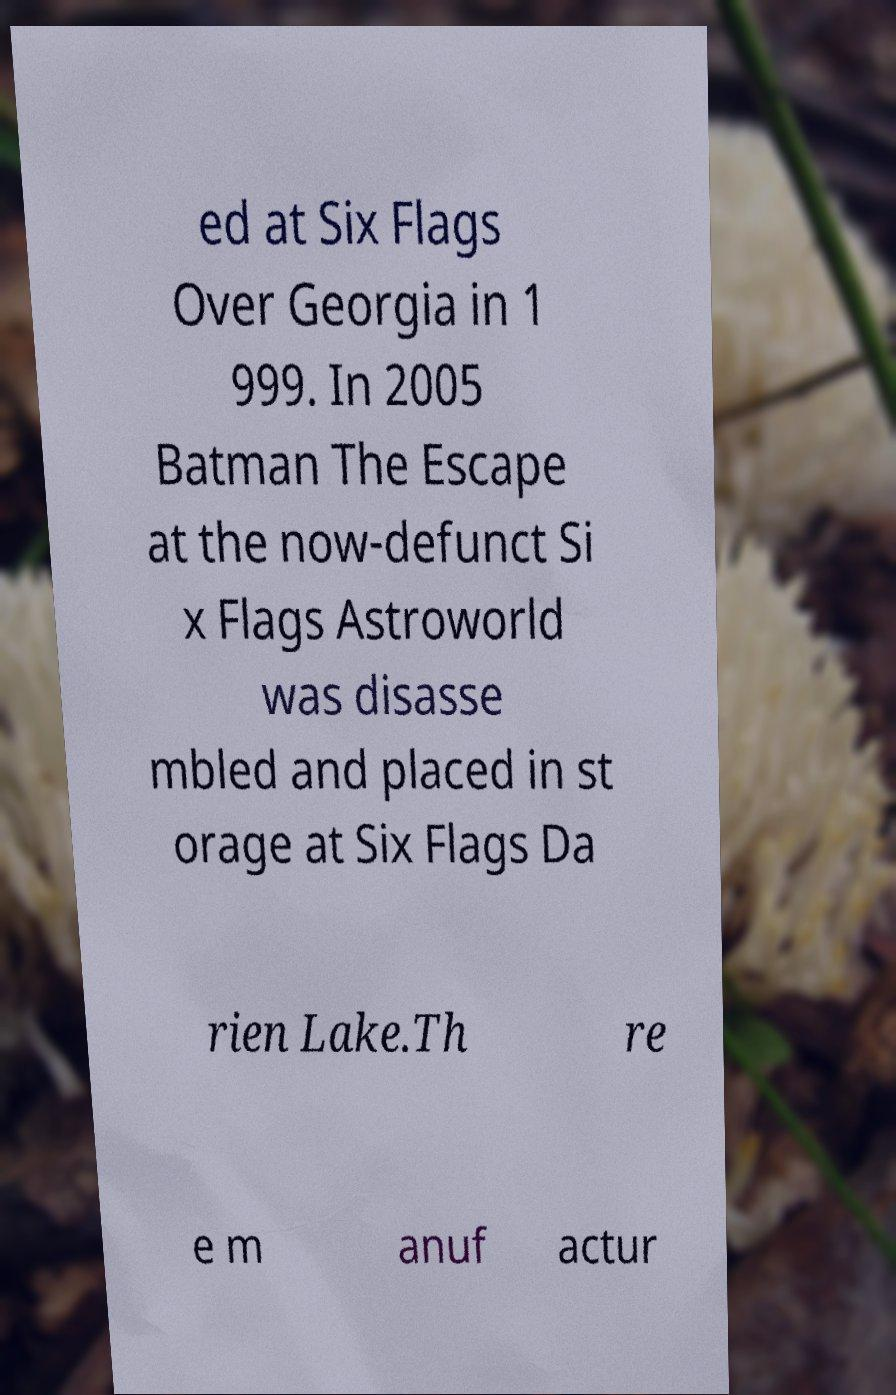Could you assist in decoding the text presented in this image and type it out clearly? ed at Six Flags Over Georgia in 1 999. In 2005 Batman The Escape at the now-defunct Si x Flags Astroworld was disasse mbled and placed in st orage at Six Flags Da rien Lake.Th re e m anuf actur 